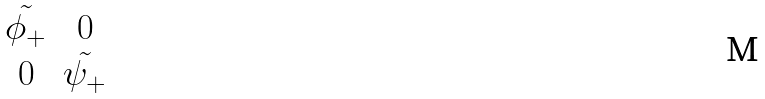<formula> <loc_0><loc_0><loc_500><loc_500>\begin{matrix} \tilde { \phi _ { + } } & 0 \\ 0 & \tilde { \psi _ { + } } \end{matrix}</formula> 